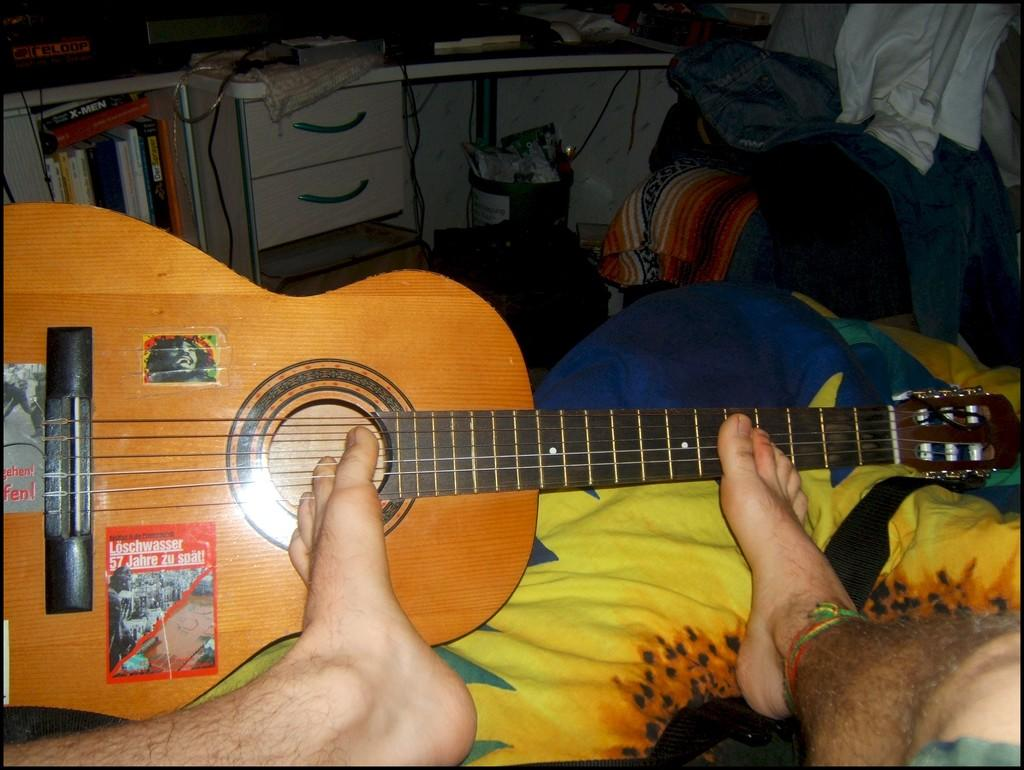Where was the image taken? The image was taken in a room. What is the man in the image doing? The man is sitting on a chair and playing a guitar. How is the man positioned on the chair? The man has his leg on the chair. What can be seen in the background of the guitar? There are books, a drawer, and a monitor in the background of the guitar. What type of wind can be seen blowing through the room in the image? There is no wind present in the image; it is an indoor setting. 